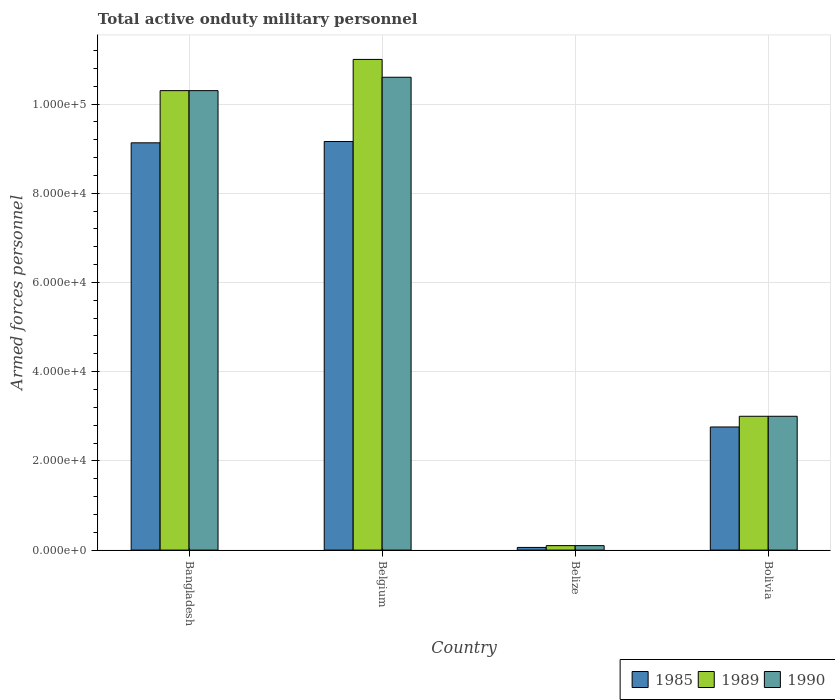How many different coloured bars are there?
Offer a very short reply. 3. Are the number of bars per tick equal to the number of legend labels?
Offer a terse response. Yes. Are the number of bars on each tick of the X-axis equal?
Provide a short and direct response. Yes. How many bars are there on the 2nd tick from the left?
Offer a very short reply. 3. How many bars are there on the 2nd tick from the right?
Keep it short and to the point. 3. In how many cases, is the number of bars for a given country not equal to the number of legend labels?
Your response must be concise. 0. What is the number of armed forces personnel in 1985 in Bolivia?
Offer a very short reply. 2.76e+04. Across all countries, what is the maximum number of armed forces personnel in 1990?
Give a very brief answer. 1.06e+05. Across all countries, what is the minimum number of armed forces personnel in 1985?
Give a very brief answer. 600. In which country was the number of armed forces personnel in 1989 maximum?
Offer a terse response. Belgium. In which country was the number of armed forces personnel in 1990 minimum?
Your answer should be compact. Belize. What is the total number of armed forces personnel in 1985 in the graph?
Provide a succinct answer. 2.11e+05. What is the difference between the number of armed forces personnel in 1985 in Belize and that in Bolivia?
Provide a short and direct response. -2.70e+04. What is the difference between the number of armed forces personnel in 1990 in Bangladesh and the number of armed forces personnel in 1989 in Belgium?
Your answer should be very brief. -7000. What is the average number of armed forces personnel in 1989 per country?
Offer a very short reply. 6.10e+04. What is the difference between the number of armed forces personnel of/in 1989 and number of armed forces personnel of/in 1985 in Bolivia?
Provide a succinct answer. 2400. What is the ratio of the number of armed forces personnel in 1989 in Belgium to that in Bolivia?
Your answer should be compact. 3.67. Is the number of armed forces personnel in 1990 in Bangladesh less than that in Belgium?
Give a very brief answer. Yes. What is the difference between the highest and the lowest number of armed forces personnel in 1989?
Your response must be concise. 1.09e+05. Is the sum of the number of armed forces personnel in 1989 in Bangladesh and Belgium greater than the maximum number of armed forces personnel in 1990 across all countries?
Offer a very short reply. Yes. What does the 1st bar from the left in Belize represents?
Provide a short and direct response. 1985. Is it the case that in every country, the sum of the number of armed forces personnel in 1989 and number of armed forces personnel in 1990 is greater than the number of armed forces personnel in 1985?
Offer a terse response. Yes. Are all the bars in the graph horizontal?
Provide a short and direct response. No. How many countries are there in the graph?
Your response must be concise. 4. Does the graph contain grids?
Make the answer very short. Yes. How many legend labels are there?
Give a very brief answer. 3. How are the legend labels stacked?
Make the answer very short. Horizontal. What is the title of the graph?
Your answer should be compact. Total active onduty military personnel. What is the label or title of the X-axis?
Provide a short and direct response. Country. What is the label or title of the Y-axis?
Offer a terse response. Armed forces personnel. What is the Armed forces personnel in 1985 in Bangladesh?
Provide a short and direct response. 9.13e+04. What is the Armed forces personnel in 1989 in Bangladesh?
Your response must be concise. 1.03e+05. What is the Armed forces personnel in 1990 in Bangladesh?
Ensure brevity in your answer.  1.03e+05. What is the Armed forces personnel in 1985 in Belgium?
Your response must be concise. 9.16e+04. What is the Armed forces personnel in 1990 in Belgium?
Your response must be concise. 1.06e+05. What is the Armed forces personnel of 1985 in Belize?
Provide a succinct answer. 600. What is the Armed forces personnel of 1990 in Belize?
Give a very brief answer. 1000. What is the Armed forces personnel of 1985 in Bolivia?
Make the answer very short. 2.76e+04. What is the Armed forces personnel of 1989 in Bolivia?
Ensure brevity in your answer.  3.00e+04. Across all countries, what is the maximum Armed forces personnel in 1985?
Give a very brief answer. 9.16e+04. Across all countries, what is the maximum Armed forces personnel of 1990?
Your answer should be compact. 1.06e+05. Across all countries, what is the minimum Armed forces personnel in 1985?
Provide a succinct answer. 600. Across all countries, what is the minimum Armed forces personnel of 1989?
Your response must be concise. 1000. What is the total Armed forces personnel of 1985 in the graph?
Provide a short and direct response. 2.11e+05. What is the total Armed forces personnel in 1989 in the graph?
Offer a terse response. 2.44e+05. What is the total Armed forces personnel in 1990 in the graph?
Provide a short and direct response. 2.40e+05. What is the difference between the Armed forces personnel in 1985 in Bangladesh and that in Belgium?
Provide a short and direct response. -300. What is the difference between the Armed forces personnel of 1989 in Bangladesh and that in Belgium?
Make the answer very short. -7000. What is the difference between the Armed forces personnel of 1990 in Bangladesh and that in Belgium?
Your answer should be very brief. -3000. What is the difference between the Armed forces personnel in 1985 in Bangladesh and that in Belize?
Your answer should be compact. 9.07e+04. What is the difference between the Armed forces personnel of 1989 in Bangladesh and that in Belize?
Provide a succinct answer. 1.02e+05. What is the difference between the Armed forces personnel of 1990 in Bangladesh and that in Belize?
Your answer should be very brief. 1.02e+05. What is the difference between the Armed forces personnel of 1985 in Bangladesh and that in Bolivia?
Your answer should be very brief. 6.37e+04. What is the difference between the Armed forces personnel in 1989 in Bangladesh and that in Bolivia?
Your response must be concise. 7.30e+04. What is the difference between the Armed forces personnel of 1990 in Bangladesh and that in Bolivia?
Provide a succinct answer. 7.30e+04. What is the difference between the Armed forces personnel of 1985 in Belgium and that in Belize?
Your response must be concise. 9.10e+04. What is the difference between the Armed forces personnel of 1989 in Belgium and that in Belize?
Your answer should be compact. 1.09e+05. What is the difference between the Armed forces personnel of 1990 in Belgium and that in Belize?
Provide a succinct answer. 1.05e+05. What is the difference between the Armed forces personnel of 1985 in Belgium and that in Bolivia?
Ensure brevity in your answer.  6.40e+04. What is the difference between the Armed forces personnel of 1989 in Belgium and that in Bolivia?
Provide a short and direct response. 8.00e+04. What is the difference between the Armed forces personnel of 1990 in Belgium and that in Bolivia?
Offer a terse response. 7.60e+04. What is the difference between the Armed forces personnel of 1985 in Belize and that in Bolivia?
Give a very brief answer. -2.70e+04. What is the difference between the Armed forces personnel in 1989 in Belize and that in Bolivia?
Your response must be concise. -2.90e+04. What is the difference between the Armed forces personnel of 1990 in Belize and that in Bolivia?
Ensure brevity in your answer.  -2.90e+04. What is the difference between the Armed forces personnel in 1985 in Bangladesh and the Armed forces personnel in 1989 in Belgium?
Your response must be concise. -1.87e+04. What is the difference between the Armed forces personnel in 1985 in Bangladesh and the Armed forces personnel in 1990 in Belgium?
Offer a terse response. -1.47e+04. What is the difference between the Armed forces personnel in 1989 in Bangladesh and the Armed forces personnel in 1990 in Belgium?
Your answer should be very brief. -3000. What is the difference between the Armed forces personnel of 1985 in Bangladesh and the Armed forces personnel of 1989 in Belize?
Ensure brevity in your answer.  9.03e+04. What is the difference between the Armed forces personnel in 1985 in Bangladesh and the Armed forces personnel in 1990 in Belize?
Make the answer very short. 9.03e+04. What is the difference between the Armed forces personnel of 1989 in Bangladesh and the Armed forces personnel of 1990 in Belize?
Make the answer very short. 1.02e+05. What is the difference between the Armed forces personnel of 1985 in Bangladesh and the Armed forces personnel of 1989 in Bolivia?
Your answer should be very brief. 6.13e+04. What is the difference between the Armed forces personnel of 1985 in Bangladesh and the Armed forces personnel of 1990 in Bolivia?
Offer a terse response. 6.13e+04. What is the difference between the Armed forces personnel of 1989 in Bangladesh and the Armed forces personnel of 1990 in Bolivia?
Provide a succinct answer. 7.30e+04. What is the difference between the Armed forces personnel in 1985 in Belgium and the Armed forces personnel in 1989 in Belize?
Your answer should be compact. 9.06e+04. What is the difference between the Armed forces personnel of 1985 in Belgium and the Armed forces personnel of 1990 in Belize?
Make the answer very short. 9.06e+04. What is the difference between the Armed forces personnel in 1989 in Belgium and the Armed forces personnel in 1990 in Belize?
Ensure brevity in your answer.  1.09e+05. What is the difference between the Armed forces personnel of 1985 in Belgium and the Armed forces personnel of 1989 in Bolivia?
Your answer should be very brief. 6.16e+04. What is the difference between the Armed forces personnel of 1985 in Belgium and the Armed forces personnel of 1990 in Bolivia?
Give a very brief answer. 6.16e+04. What is the difference between the Armed forces personnel of 1985 in Belize and the Armed forces personnel of 1989 in Bolivia?
Provide a succinct answer. -2.94e+04. What is the difference between the Armed forces personnel in 1985 in Belize and the Armed forces personnel in 1990 in Bolivia?
Offer a terse response. -2.94e+04. What is the difference between the Armed forces personnel in 1989 in Belize and the Armed forces personnel in 1990 in Bolivia?
Provide a succinct answer. -2.90e+04. What is the average Armed forces personnel in 1985 per country?
Provide a succinct answer. 5.28e+04. What is the average Armed forces personnel of 1989 per country?
Your answer should be compact. 6.10e+04. What is the average Armed forces personnel in 1990 per country?
Your answer should be very brief. 6.00e+04. What is the difference between the Armed forces personnel of 1985 and Armed forces personnel of 1989 in Bangladesh?
Offer a terse response. -1.17e+04. What is the difference between the Armed forces personnel of 1985 and Armed forces personnel of 1990 in Bangladesh?
Ensure brevity in your answer.  -1.17e+04. What is the difference between the Armed forces personnel in 1989 and Armed forces personnel in 1990 in Bangladesh?
Ensure brevity in your answer.  0. What is the difference between the Armed forces personnel in 1985 and Armed forces personnel in 1989 in Belgium?
Provide a succinct answer. -1.84e+04. What is the difference between the Armed forces personnel of 1985 and Armed forces personnel of 1990 in Belgium?
Make the answer very short. -1.44e+04. What is the difference between the Armed forces personnel of 1989 and Armed forces personnel of 1990 in Belgium?
Your answer should be compact. 4000. What is the difference between the Armed forces personnel of 1985 and Armed forces personnel of 1989 in Belize?
Make the answer very short. -400. What is the difference between the Armed forces personnel of 1985 and Armed forces personnel of 1990 in Belize?
Offer a very short reply. -400. What is the difference between the Armed forces personnel in 1989 and Armed forces personnel in 1990 in Belize?
Your response must be concise. 0. What is the difference between the Armed forces personnel of 1985 and Armed forces personnel of 1989 in Bolivia?
Your answer should be compact. -2400. What is the difference between the Armed forces personnel in 1985 and Armed forces personnel in 1990 in Bolivia?
Your answer should be very brief. -2400. What is the ratio of the Armed forces personnel of 1985 in Bangladesh to that in Belgium?
Keep it short and to the point. 1. What is the ratio of the Armed forces personnel in 1989 in Bangladesh to that in Belgium?
Your answer should be compact. 0.94. What is the ratio of the Armed forces personnel of 1990 in Bangladesh to that in Belgium?
Make the answer very short. 0.97. What is the ratio of the Armed forces personnel in 1985 in Bangladesh to that in Belize?
Keep it short and to the point. 152.17. What is the ratio of the Armed forces personnel of 1989 in Bangladesh to that in Belize?
Offer a terse response. 103. What is the ratio of the Armed forces personnel of 1990 in Bangladesh to that in Belize?
Provide a short and direct response. 103. What is the ratio of the Armed forces personnel of 1985 in Bangladesh to that in Bolivia?
Provide a short and direct response. 3.31. What is the ratio of the Armed forces personnel in 1989 in Bangladesh to that in Bolivia?
Keep it short and to the point. 3.43. What is the ratio of the Armed forces personnel in 1990 in Bangladesh to that in Bolivia?
Provide a succinct answer. 3.43. What is the ratio of the Armed forces personnel in 1985 in Belgium to that in Belize?
Make the answer very short. 152.67. What is the ratio of the Armed forces personnel in 1989 in Belgium to that in Belize?
Your answer should be very brief. 110. What is the ratio of the Armed forces personnel in 1990 in Belgium to that in Belize?
Offer a very short reply. 106. What is the ratio of the Armed forces personnel of 1985 in Belgium to that in Bolivia?
Provide a succinct answer. 3.32. What is the ratio of the Armed forces personnel in 1989 in Belgium to that in Bolivia?
Give a very brief answer. 3.67. What is the ratio of the Armed forces personnel of 1990 in Belgium to that in Bolivia?
Offer a very short reply. 3.53. What is the ratio of the Armed forces personnel of 1985 in Belize to that in Bolivia?
Make the answer very short. 0.02. What is the ratio of the Armed forces personnel of 1989 in Belize to that in Bolivia?
Provide a short and direct response. 0.03. What is the difference between the highest and the second highest Armed forces personnel in 1985?
Make the answer very short. 300. What is the difference between the highest and the second highest Armed forces personnel of 1989?
Offer a terse response. 7000. What is the difference between the highest and the second highest Armed forces personnel of 1990?
Provide a succinct answer. 3000. What is the difference between the highest and the lowest Armed forces personnel in 1985?
Offer a very short reply. 9.10e+04. What is the difference between the highest and the lowest Armed forces personnel of 1989?
Provide a short and direct response. 1.09e+05. What is the difference between the highest and the lowest Armed forces personnel of 1990?
Offer a terse response. 1.05e+05. 